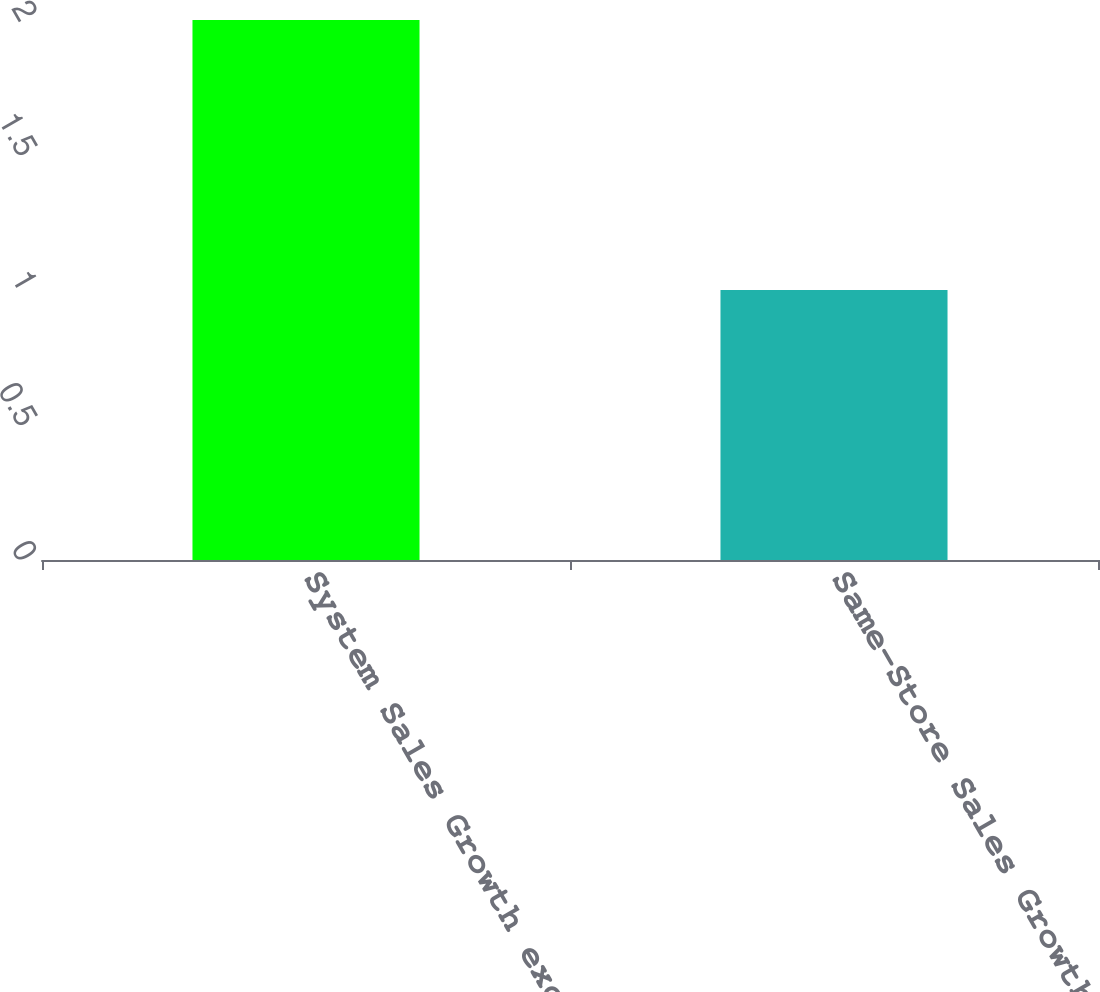<chart> <loc_0><loc_0><loc_500><loc_500><bar_chart><fcel>System Sales Growth excluding<fcel>Same-Store Sales Growth<nl><fcel>2<fcel>1<nl></chart> 